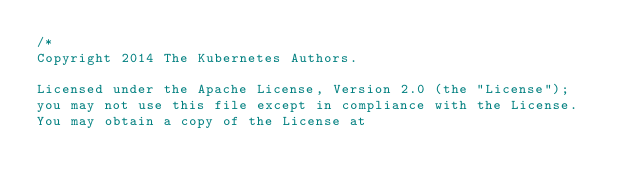<code> <loc_0><loc_0><loc_500><loc_500><_Go_>/*
Copyright 2014 The Kubernetes Authors.

Licensed under the Apache License, Version 2.0 (the "License");
you may not use this file except in compliance with the License.
You may obtain a copy of the License at
</code> 